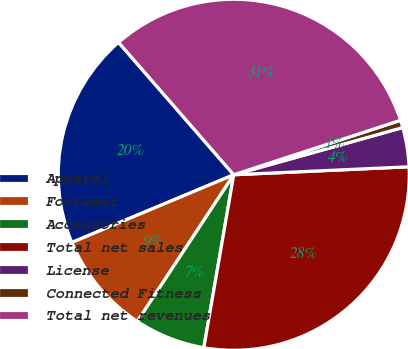Convert chart to OTSL. <chart><loc_0><loc_0><loc_500><loc_500><pie_chart><fcel>Apparel<fcel>Footwear<fcel>Accessories<fcel>Total net sales<fcel>License<fcel>Connected Fitness<fcel>Total net revenues<nl><fcel>19.91%<fcel>9.44%<fcel>6.53%<fcel>28.45%<fcel>3.61%<fcel>0.69%<fcel>31.37%<nl></chart> 